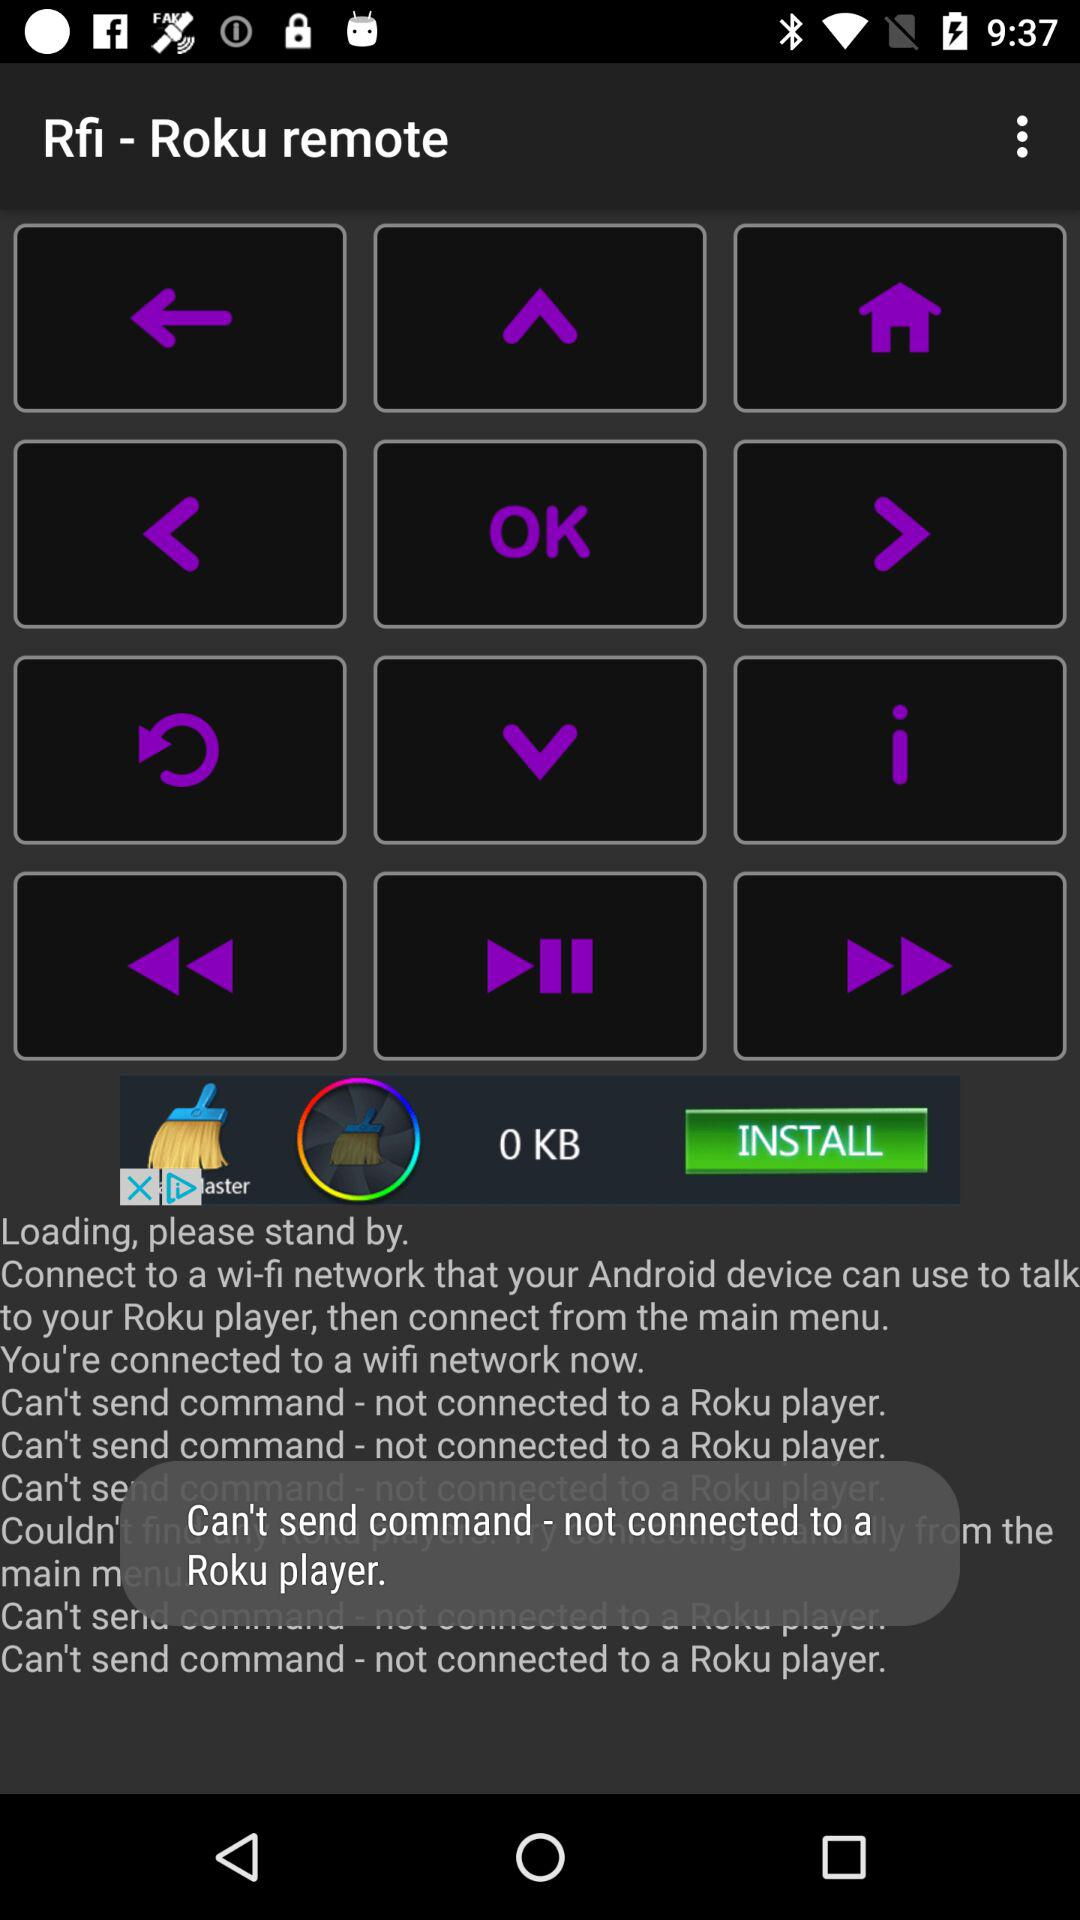What is the application name? The application name is "Rfi - Roku remote". 